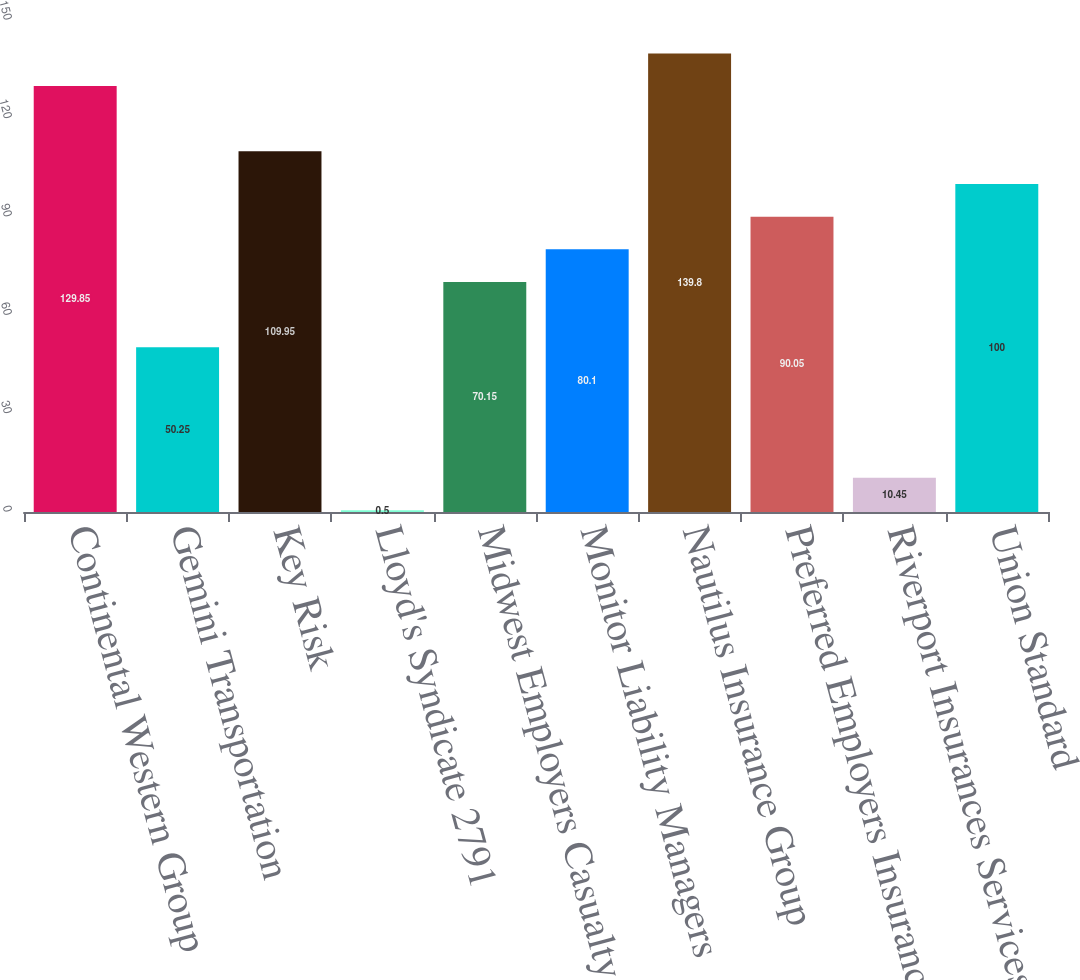<chart> <loc_0><loc_0><loc_500><loc_500><bar_chart><fcel>Continental Western Group<fcel>Gemini Transportation<fcel>Key Risk<fcel>Lloyd's Syndicate 2791<fcel>Midwest Employers Casualty<fcel>Monitor Liability Managers<fcel>Nautilus Insurance Group<fcel>Preferred Employers Insurance<fcel>Riverport Insurances Services<fcel>Union Standard<nl><fcel>129.85<fcel>50.25<fcel>109.95<fcel>0.5<fcel>70.15<fcel>80.1<fcel>139.8<fcel>90.05<fcel>10.45<fcel>100<nl></chart> 